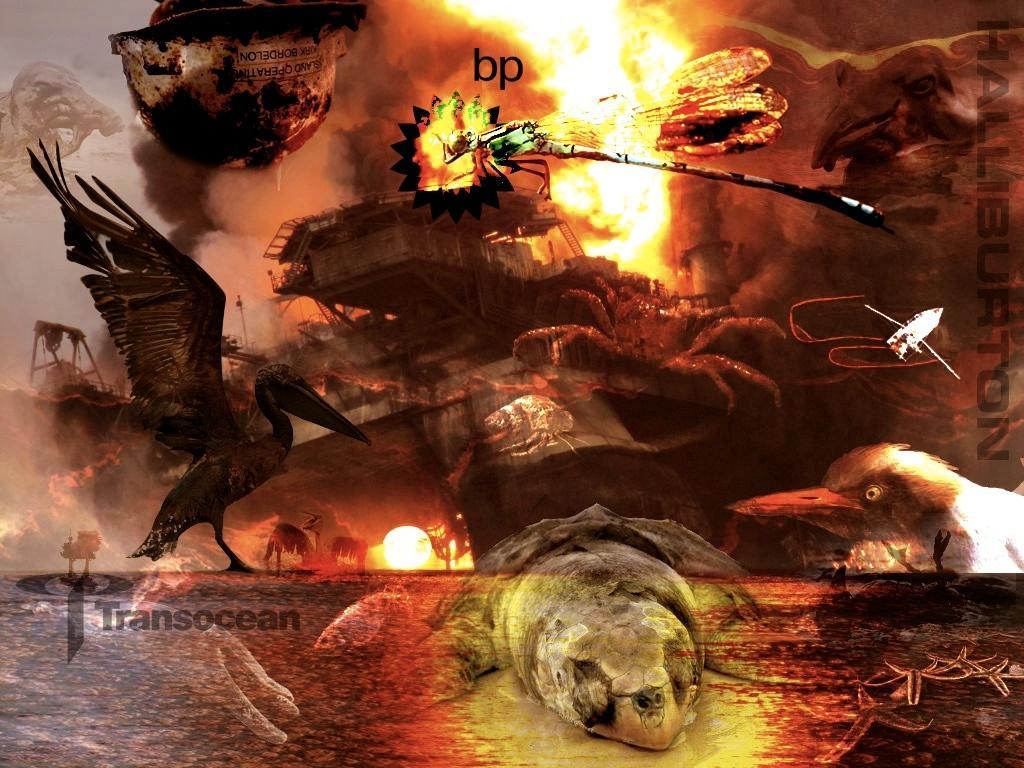Can you describe this image briefly? In this image I can see depiction picture of few animals. I can also see watermarks on every sides of the image. 